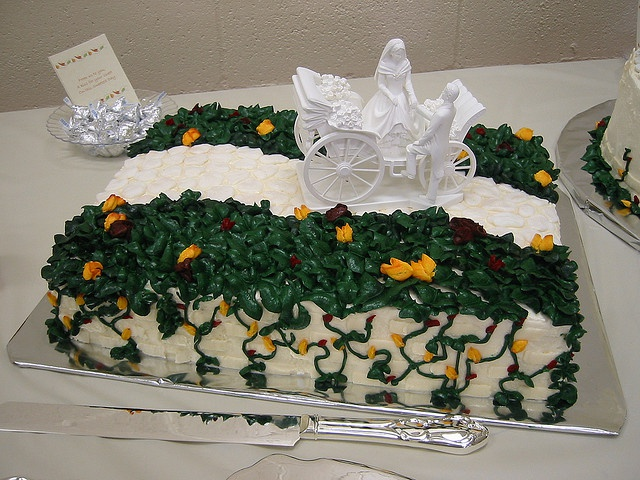Describe the objects in this image and their specific colors. I can see cake in gray, black, darkgray, and lightgray tones, knife in gray, darkgray, and white tones, cake in gray, black, and darkgray tones, and bowl in gray, darkgray, and lightgray tones in this image. 